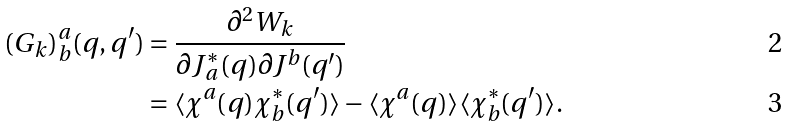<formula> <loc_0><loc_0><loc_500><loc_500>( G _ { k } ) _ { b } ^ { a } ( q , q ^ { \prime } ) & = \frac { \partial ^ { 2 } W _ { k } } { \partial J _ { a } ^ { \ast } ( q ) \partial J ^ { b } ( q ^ { \prime } ) } \\ & = \langle \chi ^ { a } ( q ) \chi _ { b } ^ { \ast } ( q ^ { \prime } ) \rangle - \langle \chi ^ { a } ( q ) \rangle \langle \chi _ { b } ^ { \ast } ( q ^ { \prime } ) \rangle .</formula> 